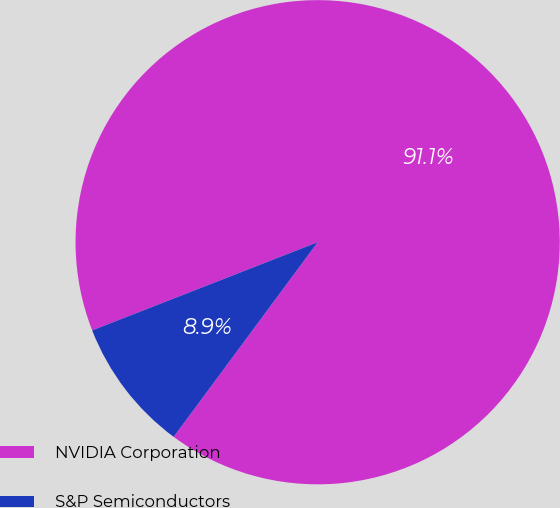Convert chart. <chart><loc_0><loc_0><loc_500><loc_500><pie_chart><fcel>NVIDIA Corporation<fcel>S&P Semiconductors<nl><fcel>91.07%<fcel>8.93%<nl></chart> 